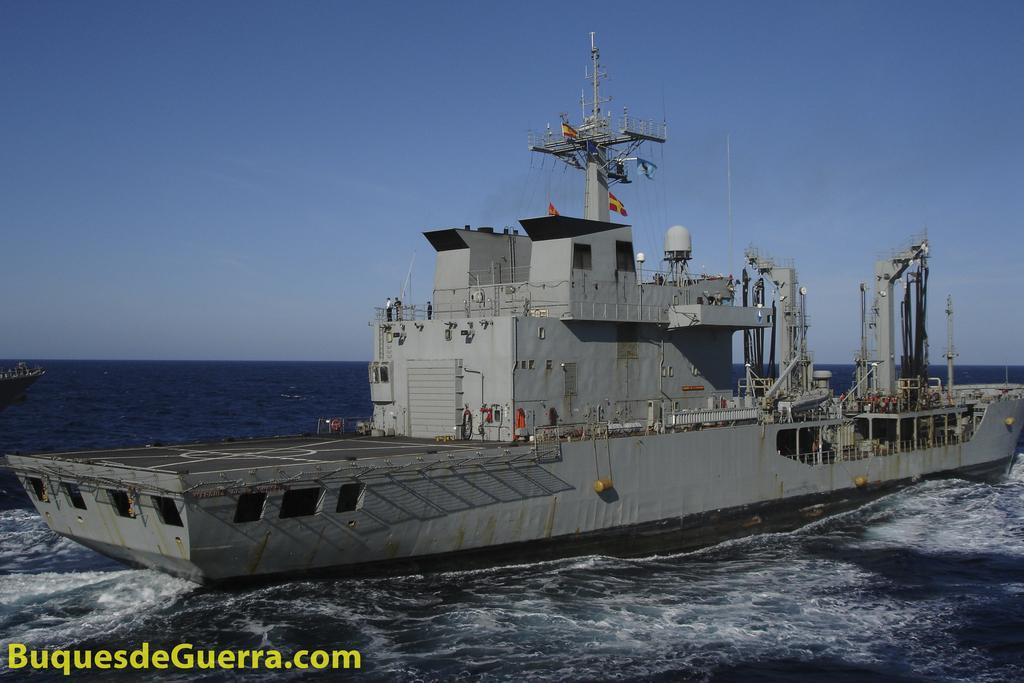Could you give a brief overview of what you see in this image? In this picture we can see one big ship in the river. 